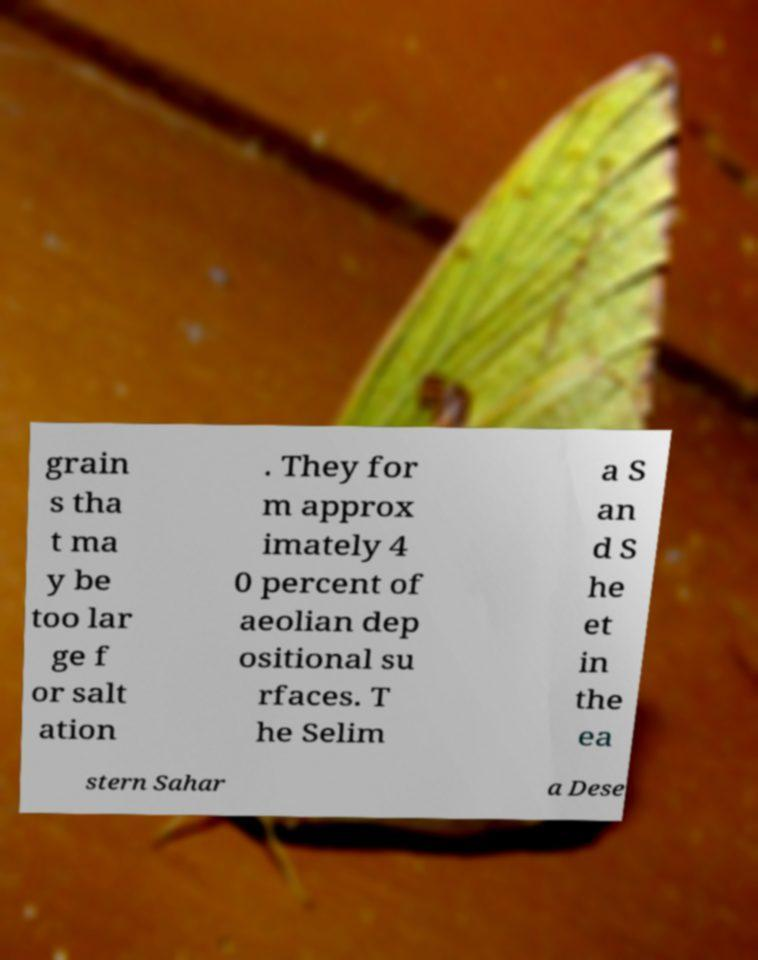Can you accurately transcribe the text from the provided image for me? grain s tha t ma y be too lar ge f or salt ation . They for m approx imately 4 0 percent of aeolian dep ositional su rfaces. T he Selim a S an d S he et in the ea stern Sahar a Dese 